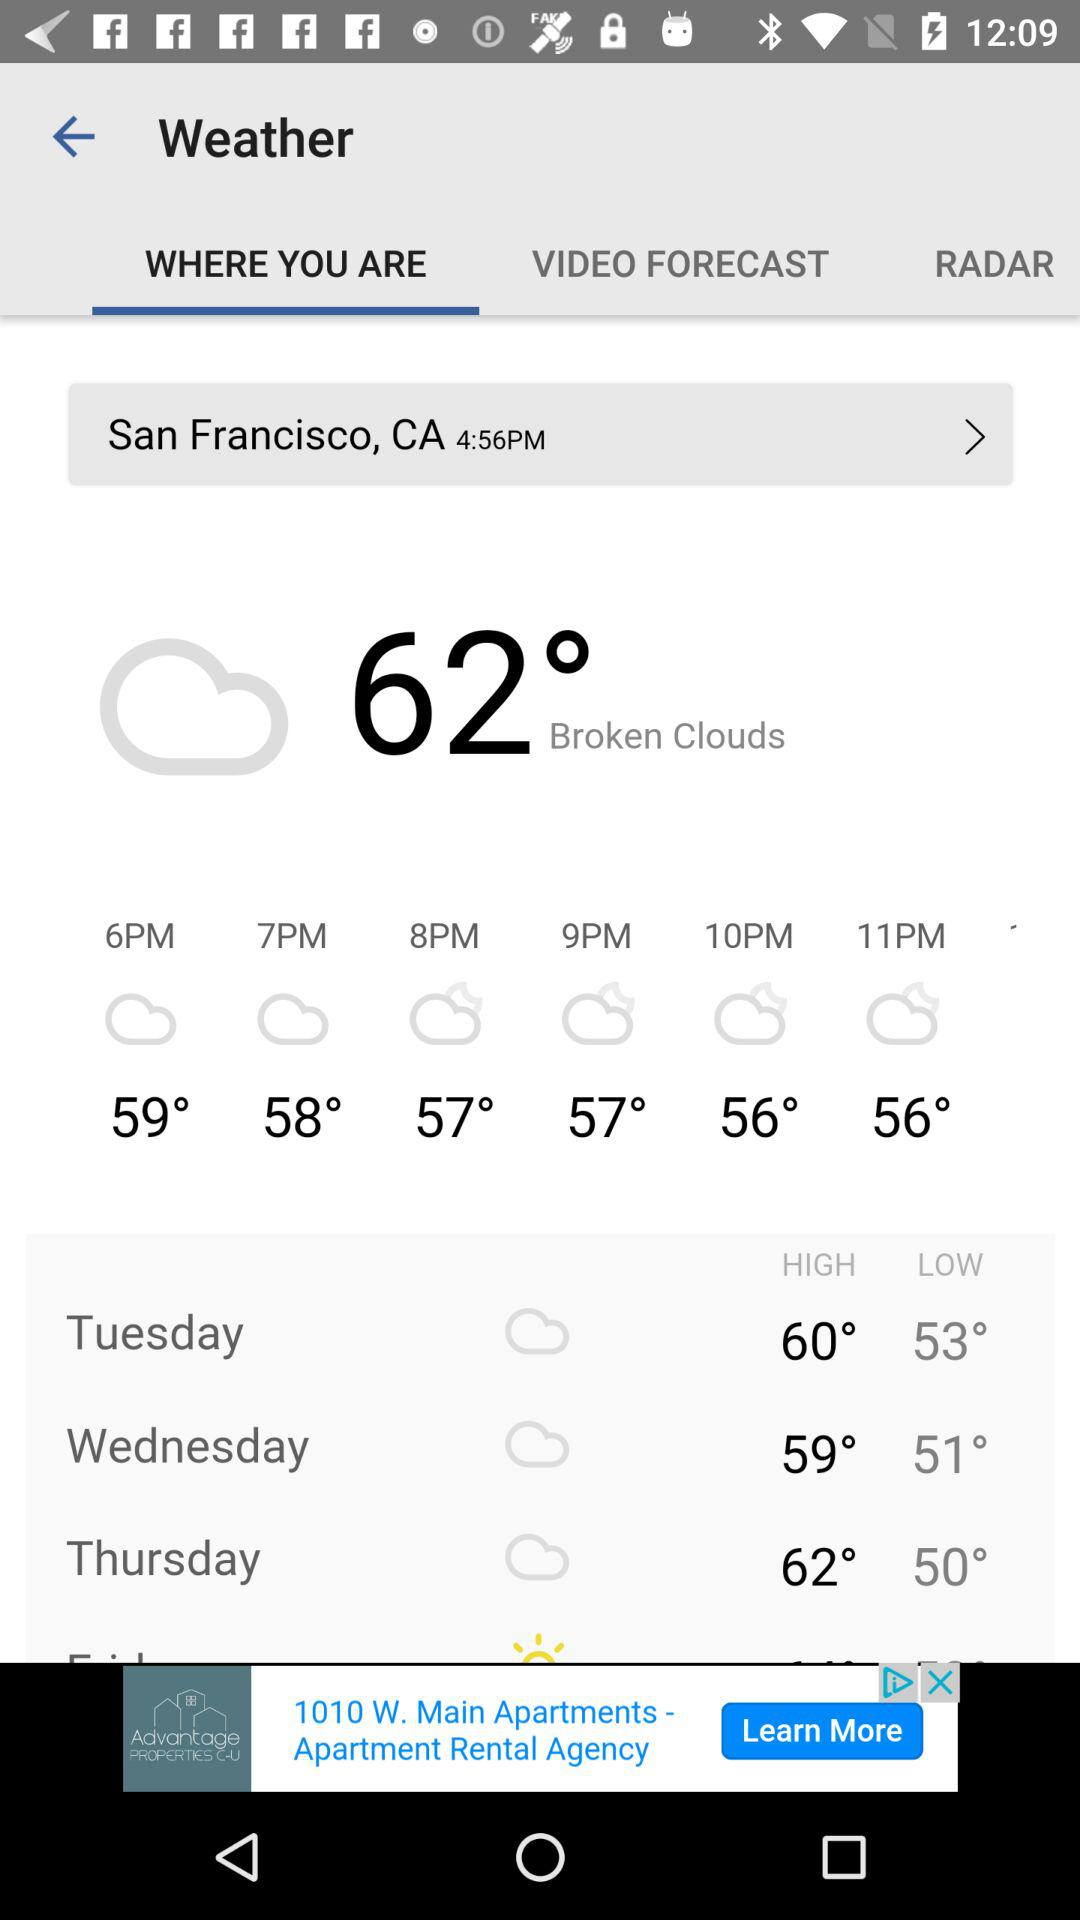What is the high temperature on Thursday? The high temperature on Thursday is 62°. 